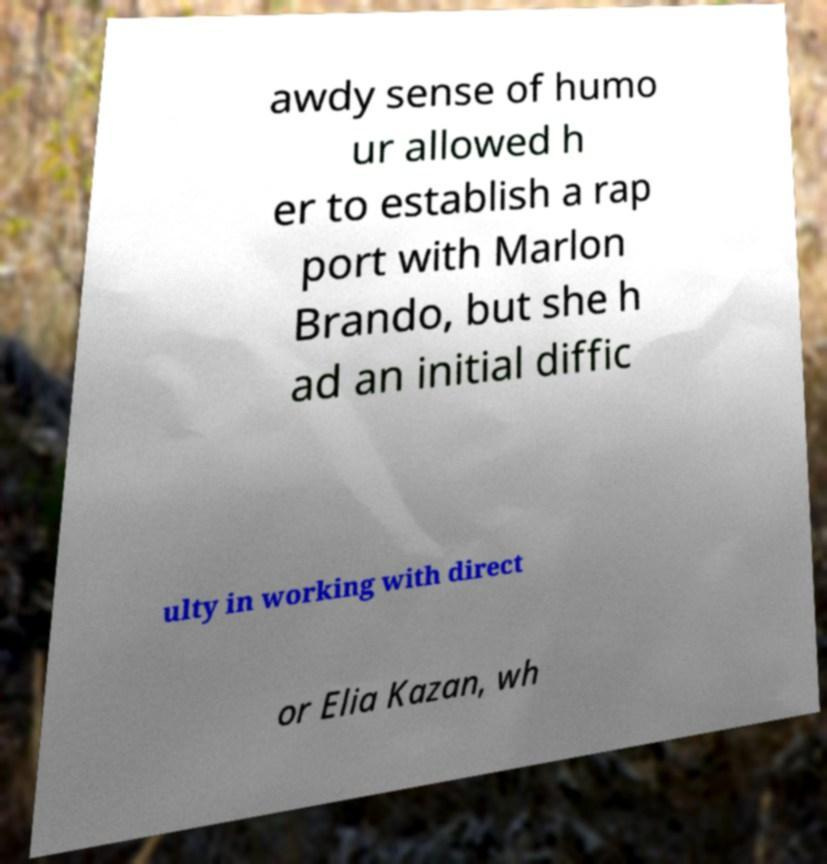Can you accurately transcribe the text from the provided image for me? awdy sense of humo ur allowed h er to establish a rap port with Marlon Brando, but she h ad an initial diffic ulty in working with direct or Elia Kazan, wh 